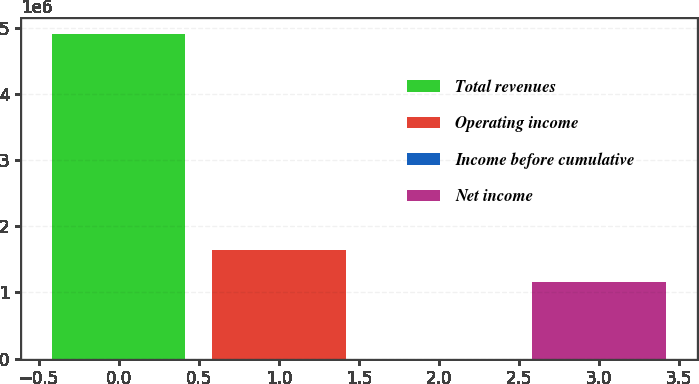Convert chart to OTSL. <chart><loc_0><loc_0><loc_500><loc_500><bar_chart><fcel>Total revenues<fcel>Operating income<fcel>Income before cumulative<fcel>Net income<nl><fcel>4.90317e+06<fcel>1.6441e+06<fcel>3.22<fcel>1.15378e+06<nl></chart> 